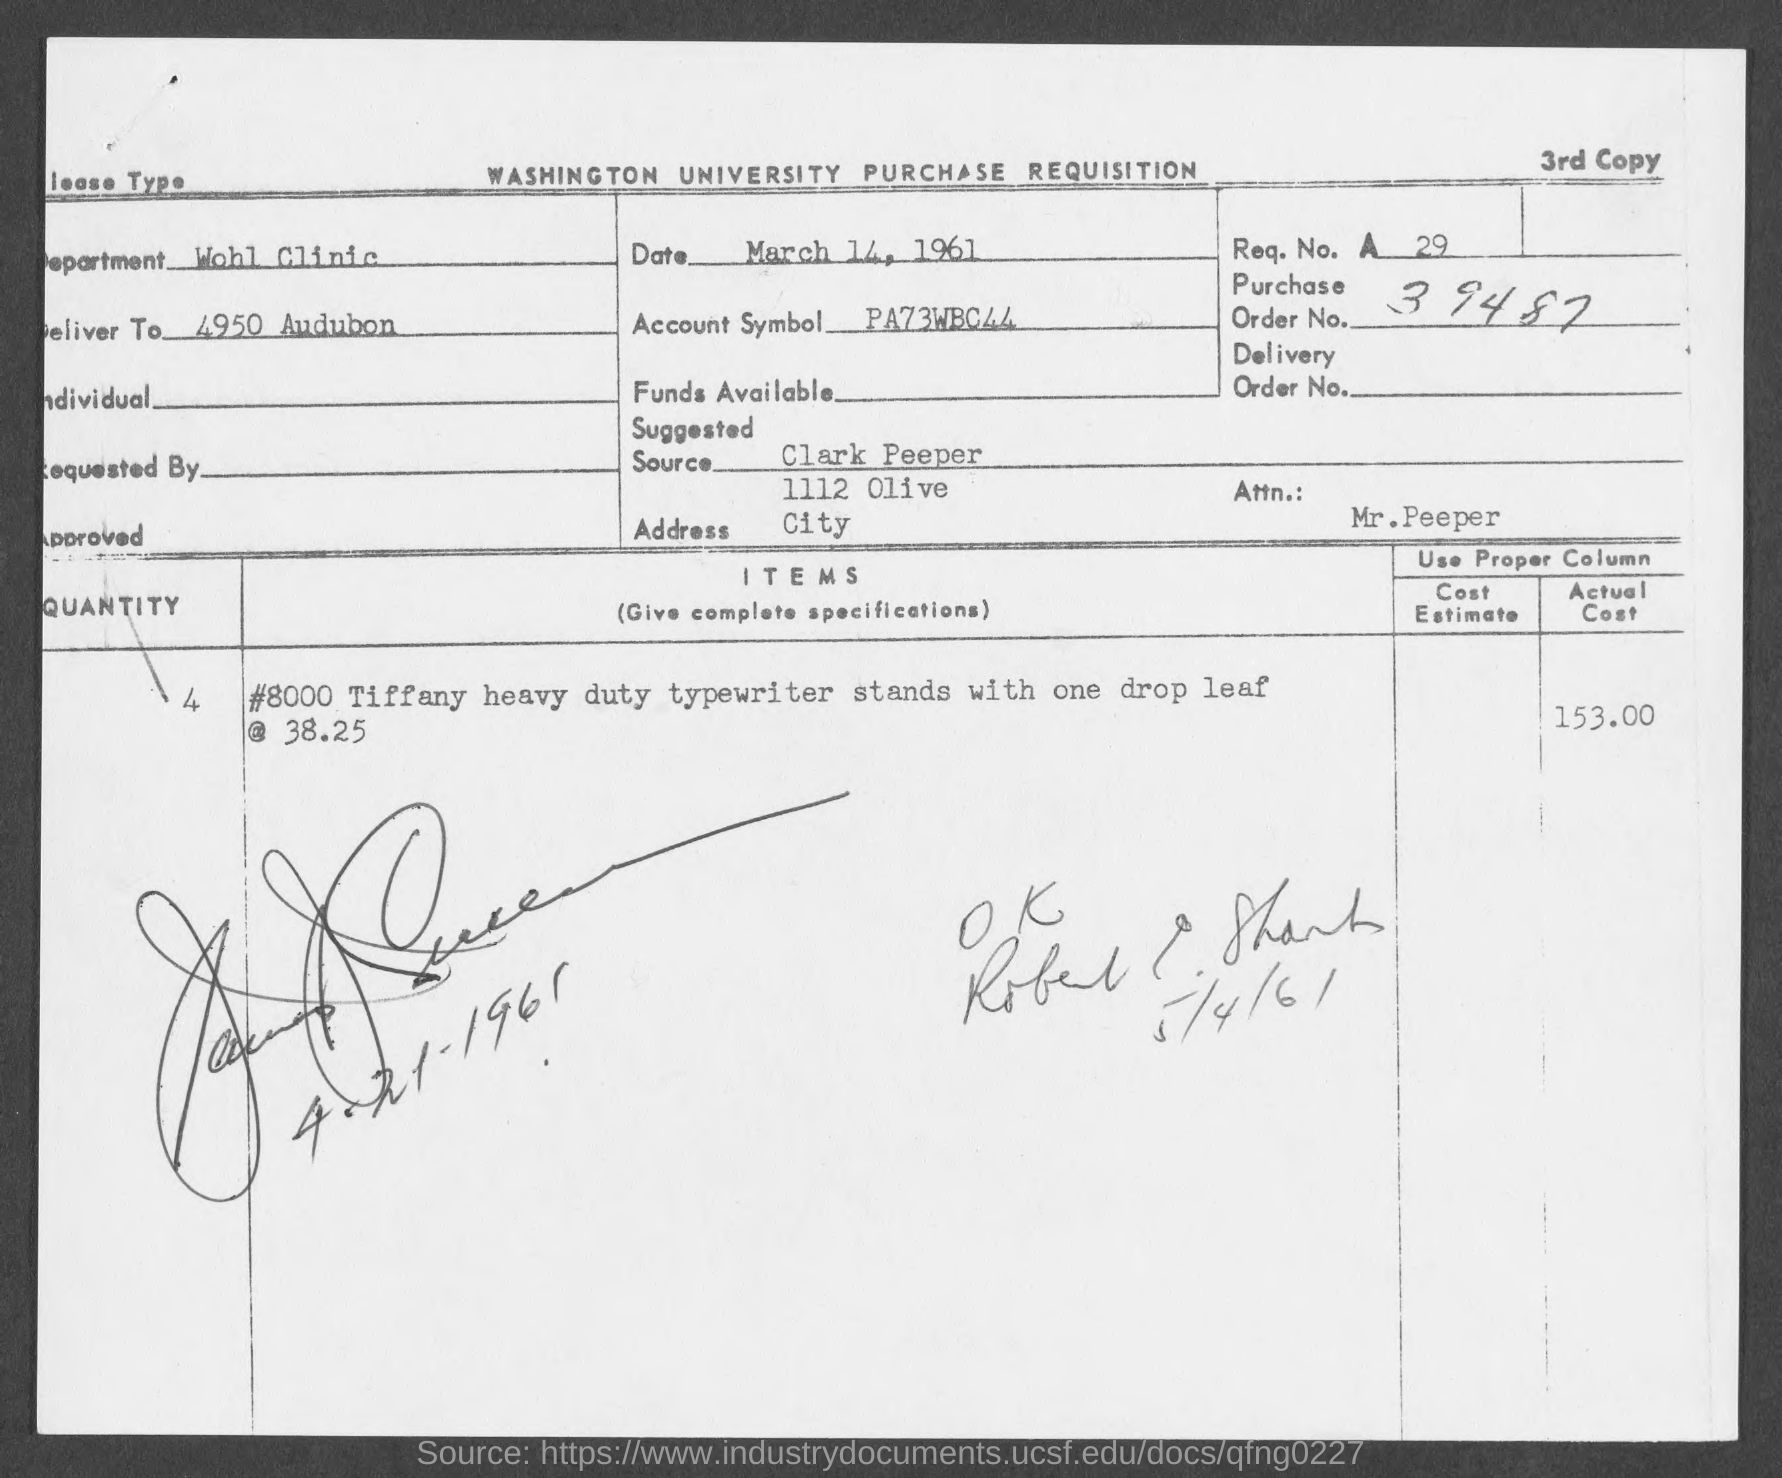What is account symbol?
Provide a short and direct response. PA73WBC44. What is the purchase order no.?
Offer a terse response. 39487. 